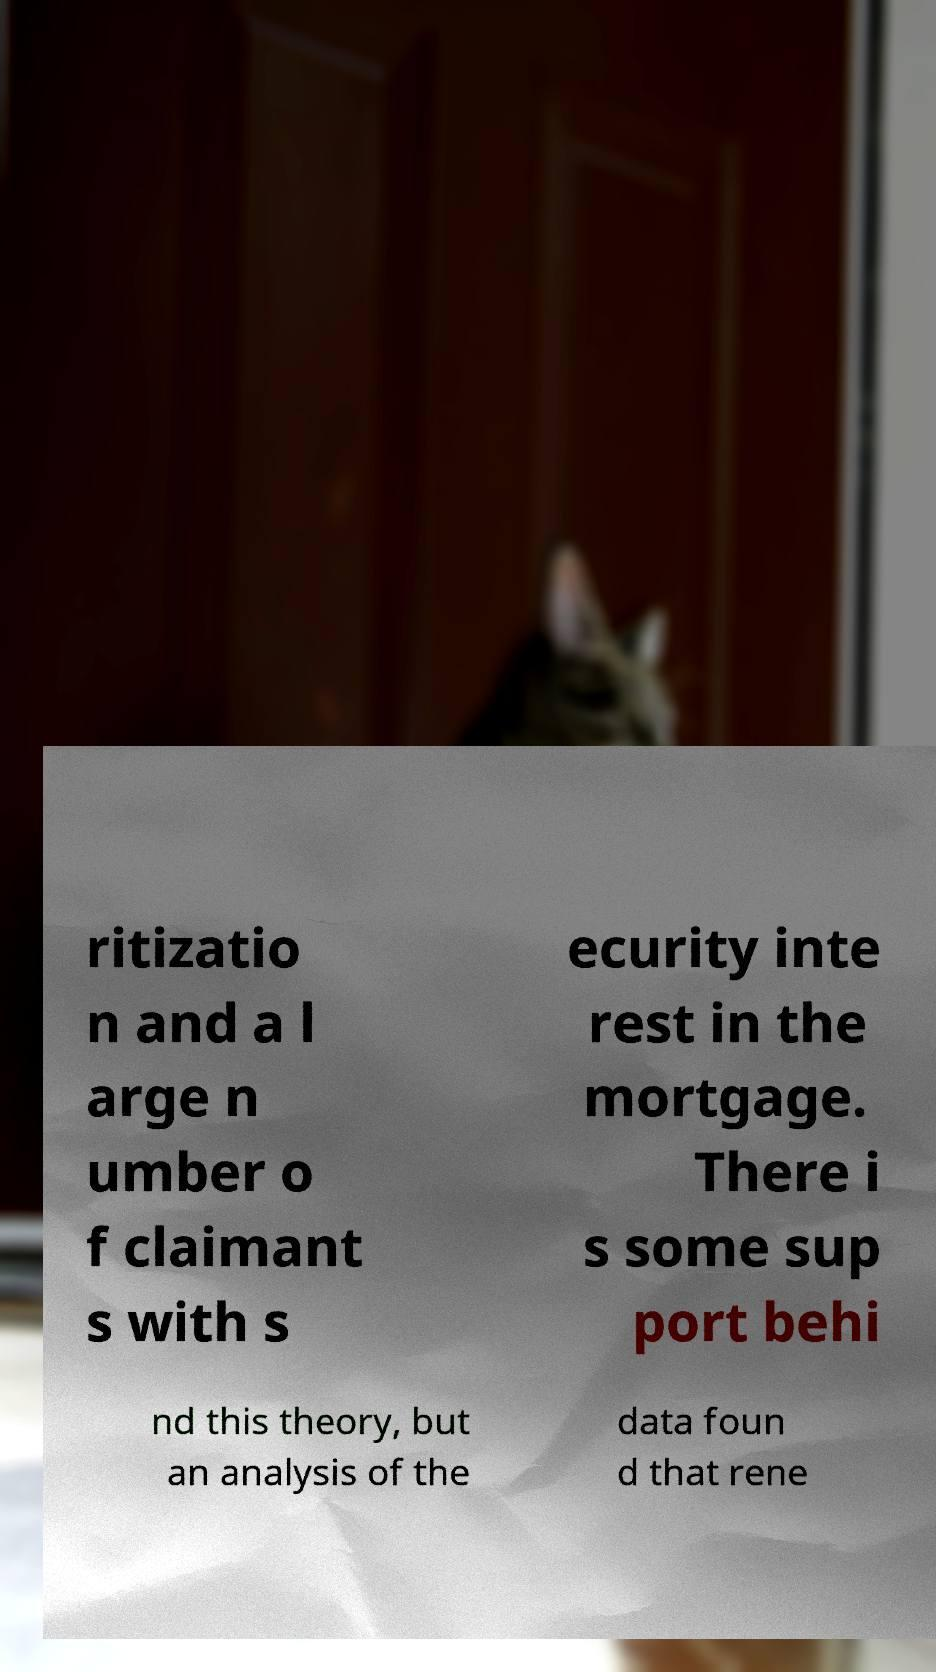Can you accurately transcribe the text from the provided image for me? ritizatio n and a l arge n umber o f claimant s with s ecurity inte rest in the mortgage. There i s some sup port behi nd this theory, but an analysis of the data foun d that rene 